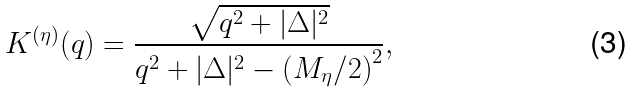Convert formula to latex. <formula><loc_0><loc_0><loc_500><loc_500>K ^ { ( \eta ) } ( q ) = \frac { \sqrt { q ^ { 2 } + | \Delta | ^ { 2 } } } { q ^ { 2 } + | \Delta | ^ { 2 } - \left ( M _ { \eta } / 2 \right ) ^ { 2 } } ,</formula> 